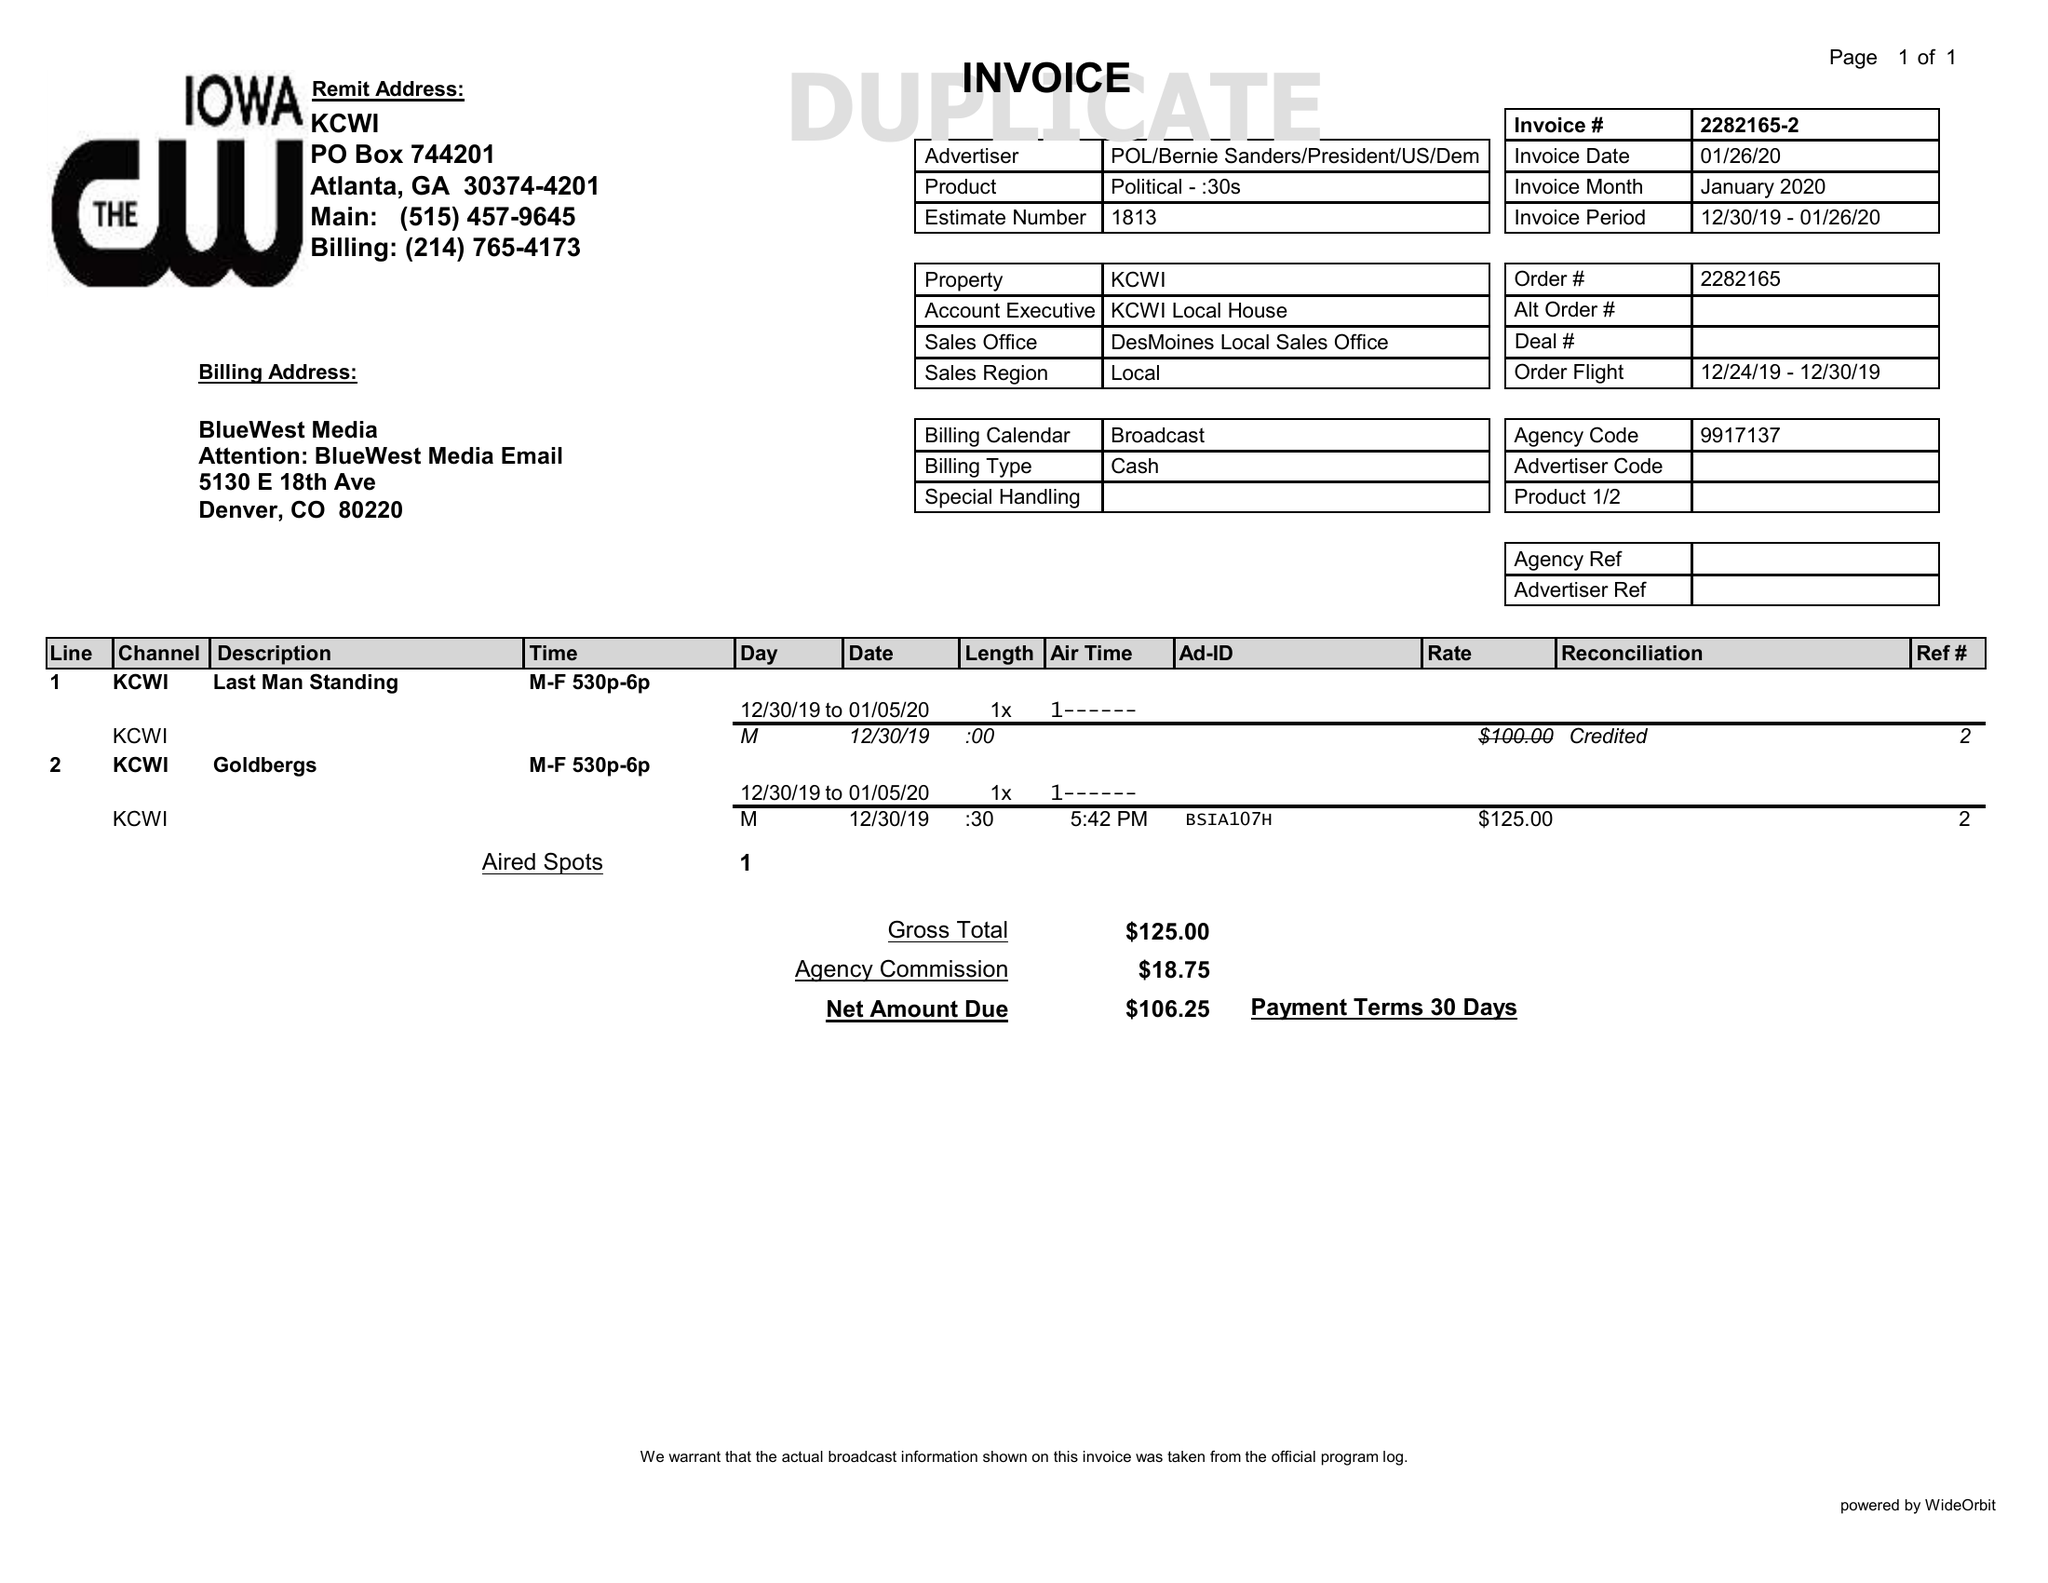What is the value for the flight_from?
Answer the question using a single word or phrase. 12/24/19 